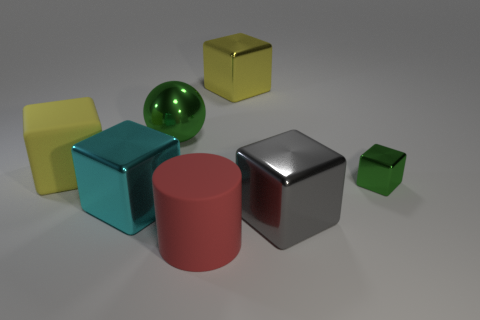There is a green metallic thing that is on the left side of the gray shiny thing; is it the same shape as the big yellow object that is right of the large cyan thing?
Offer a very short reply. No. Is the number of yellow metal cubes that are on the left side of the red cylinder the same as the number of cyan blocks?
Provide a succinct answer. No. There is a tiny thing that is the same shape as the big cyan thing; what color is it?
Provide a short and direct response. Green. Are the large cube that is behind the yellow rubber thing and the large cyan object made of the same material?
Keep it short and to the point. Yes. What number of tiny objects are either gray things or green metallic things?
Keep it short and to the point. 1. What is the size of the yellow rubber block?
Keep it short and to the point. Large. Is the size of the red object the same as the yellow cube in front of the big green shiny object?
Give a very brief answer. Yes. How many purple things are either shiny things or matte cylinders?
Give a very brief answer. 0. How many big green things are there?
Offer a very short reply. 1. There is a shiny cube on the left side of the matte cylinder; what size is it?
Keep it short and to the point. Large. 